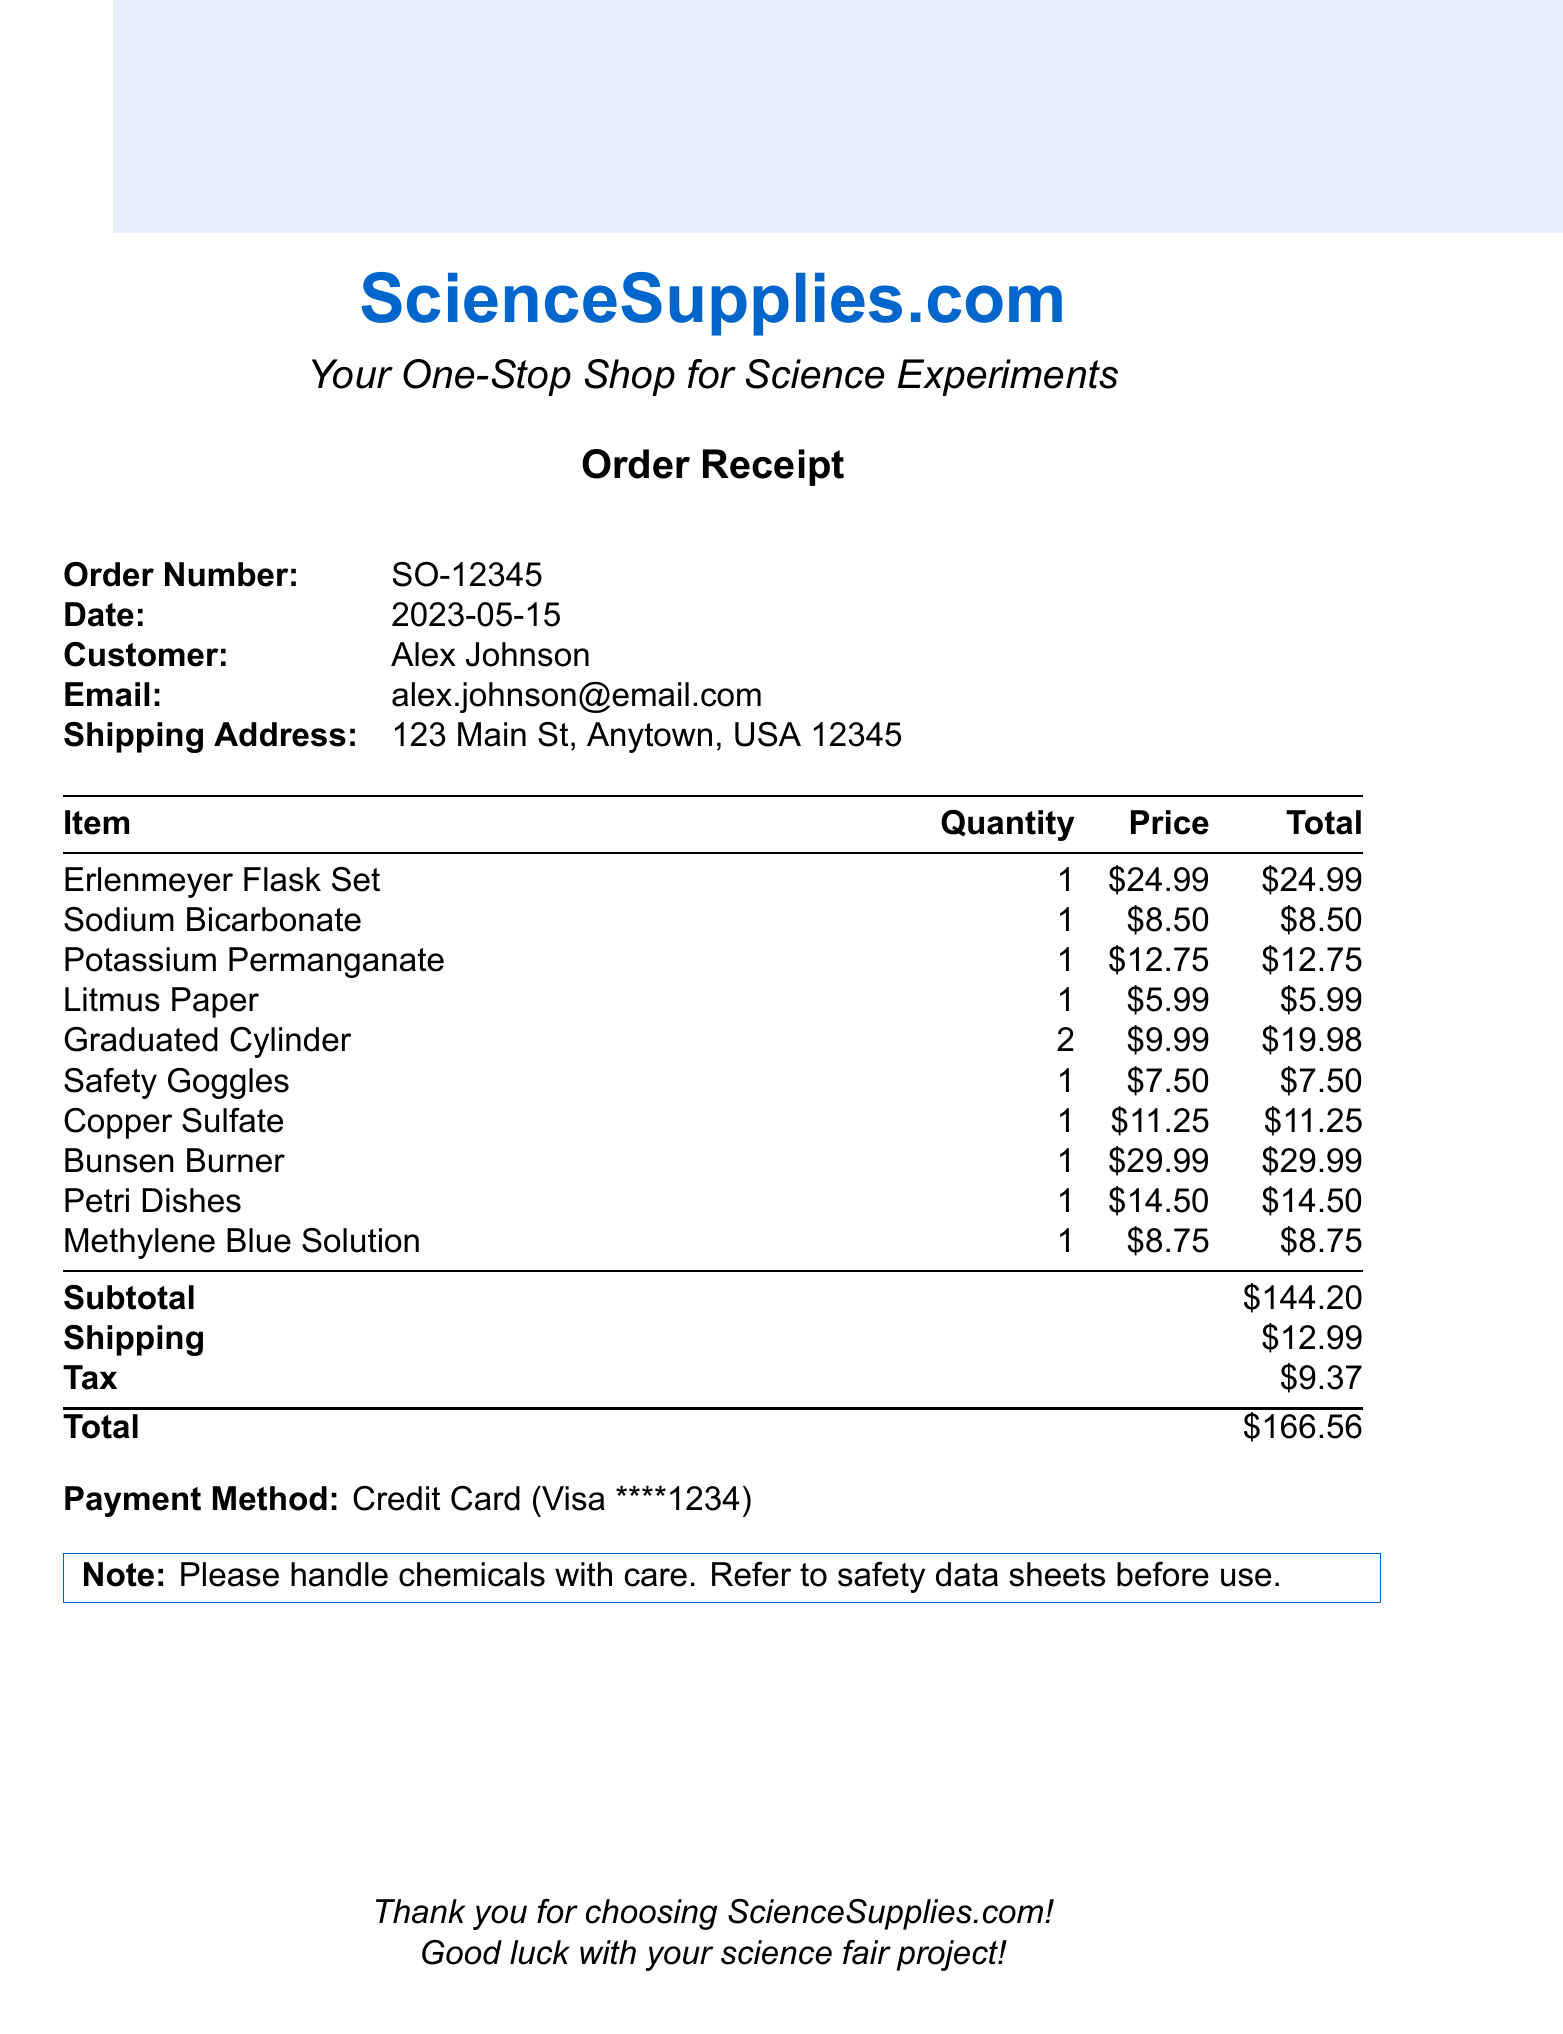What is the order number? The order number is listed at the top of the receipt for reference and is SO-12345.
Answer: SO-12345 What is the total cost of the order? The total cost at the bottom of the receipt summarizes all charges and is $166.56.
Answer: $166.56 How many Erlenmeyer flasks are included in the set? The description of the Erlenmeyer Flask Set specifies that it contains 3 flasks in different sizes.
Answer: 3 What date was the order placed? The date of the order is mentioned clearly on the receipt and is 2023-05-15.
Answer: 2023-05-15 What chemical is sold in a quantity of 500 grams? The receipt includes Sodium Bicarbonate, which is sold in a quantity of 500 grams.
Answer: Sodium Bicarbonate How much do the two Graduated Cylinders cost in total? The unit price of each Graduated Cylinder is $9.99, so for two it totals $19.98.
Answer: $19.98 What type of payment method was used? The payment method is indicated in the receipt and is a Credit Card (Visa).
Answer: Credit Card (Visa) What is the shipping cost? The shipping cost is listed on the receipt and is $12.99.
Answer: $12.99 What important note is included on the receipt? The note advises handling chemicals with care and to refer to safety data sheets before use.
Answer: Please handle chemicals with care. Refer to safety data sheets before use 